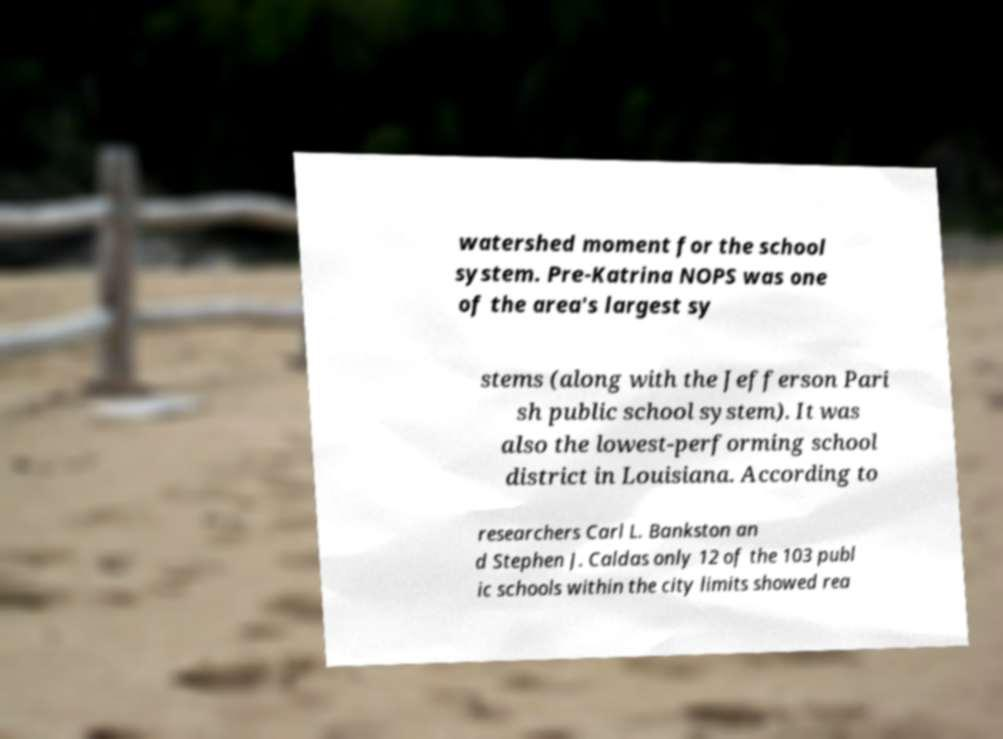Could you extract and type out the text from this image? watershed moment for the school system. Pre-Katrina NOPS was one of the area's largest sy stems (along with the Jefferson Pari sh public school system). It was also the lowest-performing school district in Louisiana. According to researchers Carl L. Bankston an d Stephen J. Caldas only 12 of the 103 publ ic schools within the city limits showed rea 